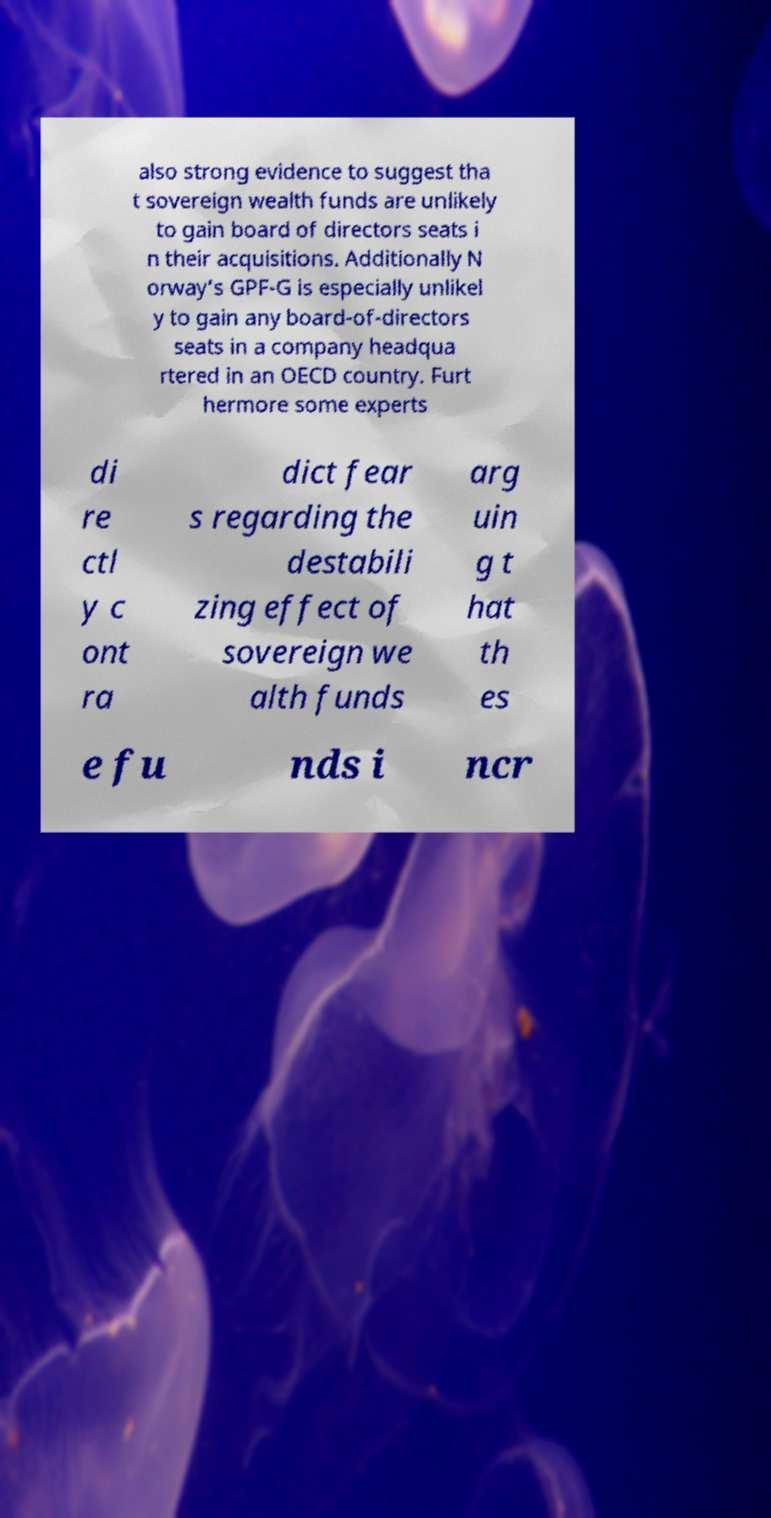What messages or text are displayed in this image? I need them in a readable, typed format. also strong evidence to suggest tha t sovereign wealth funds are unlikely to gain board of directors seats i n their acquisitions. Additionally N orway’s GPF-G is especially unlikel y to gain any board-of-directors seats in a company headqua rtered in an OECD country. Furt hermore some experts di re ctl y c ont ra dict fear s regarding the destabili zing effect of sovereign we alth funds arg uin g t hat th es e fu nds i ncr 